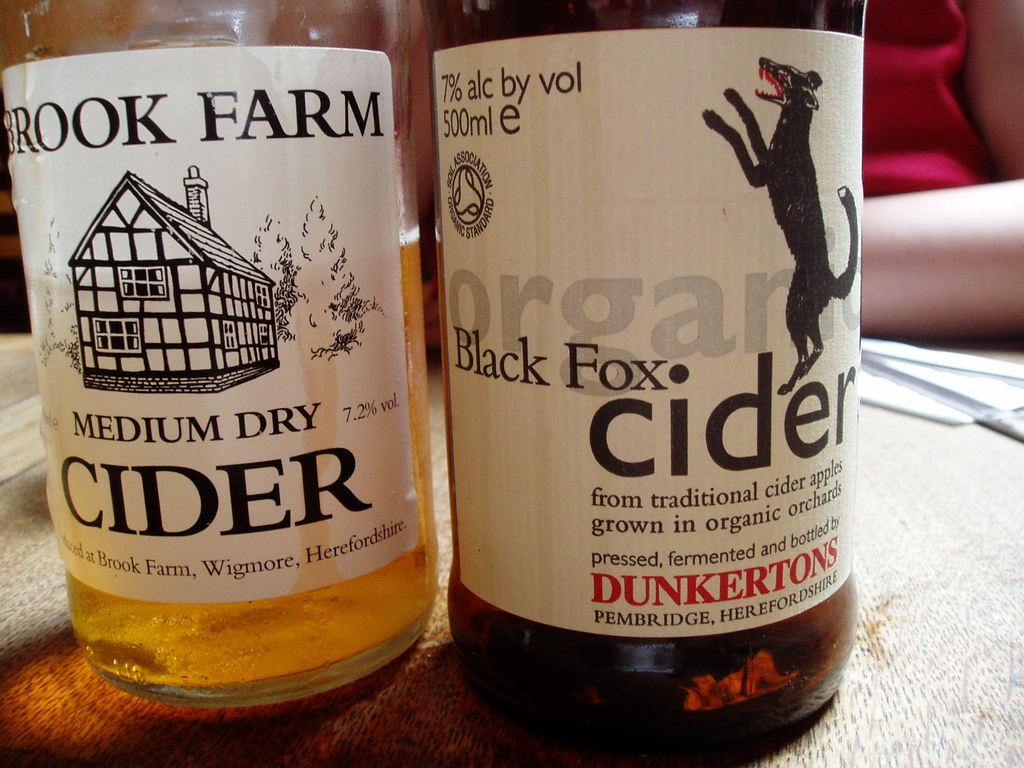What objects are on the table in the image? There are two bottles on a table in the image. Can you describe the setting or environment in the image? There is a person in the background of the image, but no specific details about the setting are provided. What type of quince is being used to make an agreement in the image? There is no quince or agreement present in the image; it only features two bottles on a table and a person in the background. 